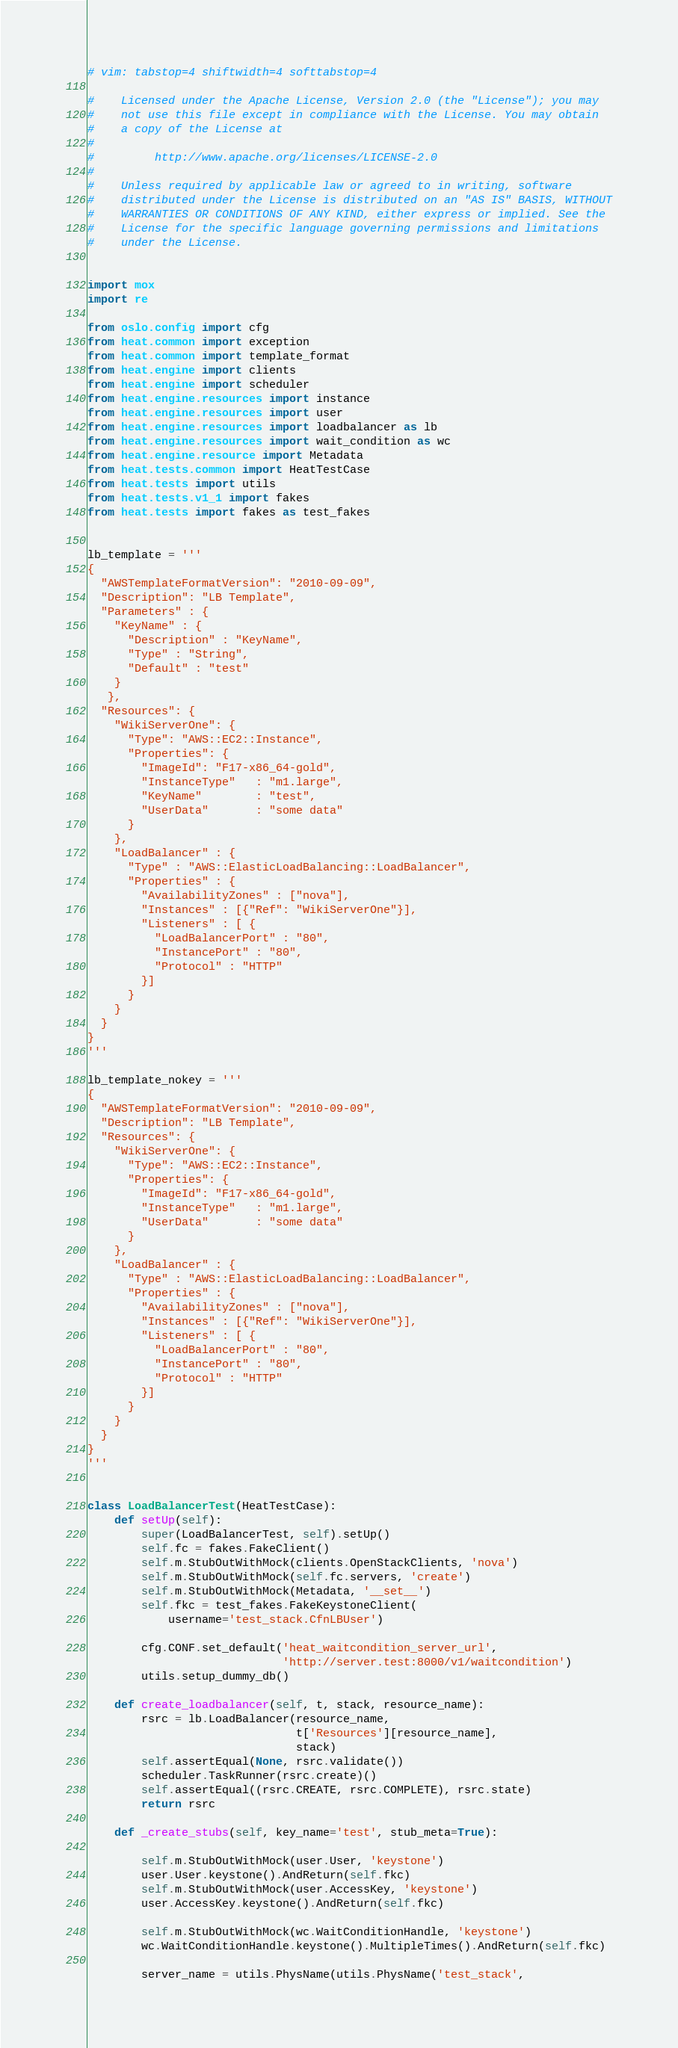Convert code to text. <code><loc_0><loc_0><loc_500><loc_500><_Python_># vim: tabstop=4 shiftwidth=4 softtabstop=4

#    Licensed under the Apache License, Version 2.0 (the "License"); you may
#    not use this file except in compliance with the License. You may obtain
#    a copy of the License at
#
#         http://www.apache.org/licenses/LICENSE-2.0
#
#    Unless required by applicable law or agreed to in writing, software
#    distributed under the License is distributed on an "AS IS" BASIS, WITHOUT
#    WARRANTIES OR CONDITIONS OF ANY KIND, either express or implied. See the
#    License for the specific language governing permissions and limitations
#    under the License.


import mox
import re

from oslo.config import cfg
from heat.common import exception
from heat.common import template_format
from heat.engine import clients
from heat.engine import scheduler
from heat.engine.resources import instance
from heat.engine.resources import user
from heat.engine.resources import loadbalancer as lb
from heat.engine.resources import wait_condition as wc
from heat.engine.resource import Metadata
from heat.tests.common import HeatTestCase
from heat.tests import utils
from heat.tests.v1_1 import fakes
from heat.tests import fakes as test_fakes


lb_template = '''
{
  "AWSTemplateFormatVersion": "2010-09-09",
  "Description": "LB Template",
  "Parameters" : {
    "KeyName" : {
      "Description" : "KeyName",
      "Type" : "String",
      "Default" : "test"
    }
   },
  "Resources": {
    "WikiServerOne": {
      "Type": "AWS::EC2::Instance",
      "Properties": {
        "ImageId": "F17-x86_64-gold",
        "InstanceType"   : "m1.large",
        "KeyName"        : "test",
        "UserData"       : "some data"
      }
    },
    "LoadBalancer" : {
      "Type" : "AWS::ElasticLoadBalancing::LoadBalancer",
      "Properties" : {
        "AvailabilityZones" : ["nova"],
        "Instances" : [{"Ref": "WikiServerOne"}],
        "Listeners" : [ {
          "LoadBalancerPort" : "80",
          "InstancePort" : "80",
          "Protocol" : "HTTP"
        }]
      }
    }
  }
}
'''

lb_template_nokey = '''
{
  "AWSTemplateFormatVersion": "2010-09-09",
  "Description": "LB Template",
  "Resources": {
    "WikiServerOne": {
      "Type": "AWS::EC2::Instance",
      "Properties": {
        "ImageId": "F17-x86_64-gold",
        "InstanceType"   : "m1.large",
        "UserData"       : "some data"
      }
    },
    "LoadBalancer" : {
      "Type" : "AWS::ElasticLoadBalancing::LoadBalancer",
      "Properties" : {
        "AvailabilityZones" : ["nova"],
        "Instances" : [{"Ref": "WikiServerOne"}],
        "Listeners" : [ {
          "LoadBalancerPort" : "80",
          "InstancePort" : "80",
          "Protocol" : "HTTP"
        }]
      }
    }
  }
}
'''


class LoadBalancerTest(HeatTestCase):
    def setUp(self):
        super(LoadBalancerTest, self).setUp()
        self.fc = fakes.FakeClient()
        self.m.StubOutWithMock(clients.OpenStackClients, 'nova')
        self.m.StubOutWithMock(self.fc.servers, 'create')
        self.m.StubOutWithMock(Metadata, '__set__')
        self.fkc = test_fakes.FakeKeystoneClient(
            username='test_stack.CfnLBUser')

        cfg.CONF.set_default('heat_waitcondition_server_url',
                             'http://server.test:8000/v1/waitcondition')
        utils.setup_dummy_db()

    def create_loadbalancer(self, t, stack, resource_name):
        rsrc = lb.LoadBalancer(resource_name,
                               t['Resources'][resource_name],
                               stack)
        self.assertEqual(None, rsrc.validate())
        scheduler.TaskRunner(rsrc.create)()
        self.assertEqual((rsrc.CREATE, rsrc.COMPLETE), rsrc.state)
        return rsrc

    def _create_stubs(self, key_name='test', stub_meta=True):

        self.m.StubOutWithMock(user.User, 'keystone')
        user.User.keystone().AndReturn(self.fkc)
        self.m.StubOutWithMock(user.AccessKey, 'keystone')
        user.AccessKey.keystone().AndReturn(self.fkc)

        self.m.StubOutWithMock(wc.WaitConditionHandle, 'keystone')
        wc.WaitConditionHandle.keystone().MultipleTimes().AndReturn(self.fkc)

        server_name = utils.PhysName(utils.PhysName('test_stack',</code> 